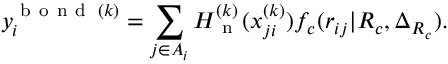<formula> <loc_0><loc_0><loc_500><loc_500>y _ { i } ^ { b o n d \, ( k ) } = \sum _ { j \in A _ { i } } H _ { n } ^ { ( k ) } ( x _ { j i } ^ { ( k ) } ) f _ { c } ( r _ { i j } | R _ { c } , \Delta _ { R _ { c } } ) .</formula> 